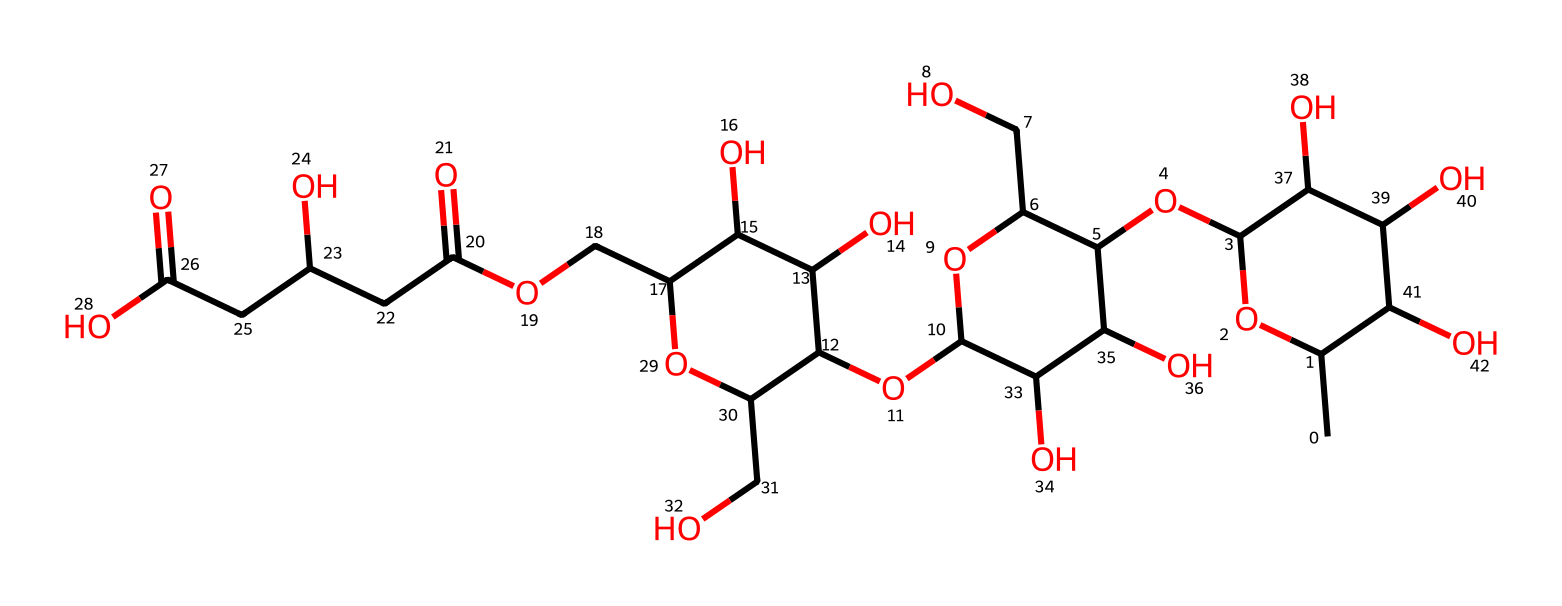What is the molecular formula of xanthan gum? To determine the molecular formula, we need to count each type of atom represented in the chemical structure. The structure given suggests the presence of carbons (C), oxygens (O), and hydrogens (H). By analyzing the structure, we identify there are 35 carbon atoms, 55 hydrogen atoms, and 30 oxygen atoms. Therefore, the molecular formula can be written as C35H55O30.
Answer: C35H55O30 How many rings are present in the structure of xanthan gum? By examining the chemical structure, we can identify the number of cyclic components or rings. In the provided SMILES representation, we can see that there are three cyclization points that indicate ring structures. This reveals that xanthan gum contains three rings in its molecular architecture.
Answer: 3 What type of functional groups can be found in xanthan gum? Understanding the classification of functional groups is essential. In the case of xanthan gum, the structure reveals the presence of hydroxyl (-OH) groups prominently due to the multiple alcohols associated with the cyclic structures, indicating its hydrophilic nature. The ether linkages can also be noted from the oxygen atoms connecting carbons. Thus, xanthan gum primarily features alcohol and ether functional groups.
Answer: alcohol, ether What is the significance of the branched structure in xanthan gum? The branched structure allows xanthan gum to exhibit its Non-Newtonian fluid characteristics, meaning its viscosity changes under stress. The multiple branches increase the complexity of the molecular interactions, allowing xanthan gum to thicken solutions effectively and provide stability without settling. The branched structure is crucial for enhancing the thickening behavior crucial in food applications.
Answer: enhances thickening How does the molecular weight of xanthan gum relate to its properties as a food thickener? The molecular weight plays a critical role in the functionality of xanthan gum. A higher molecular weight typically results in a greater ability to form viscous solutions. Xanthan gum usually has a molecular weight range of about 1 to 2 million daltons, allowing for its effective thickening and stabilizing ability in various food products.
Answer: 1 to 2 million daltons 